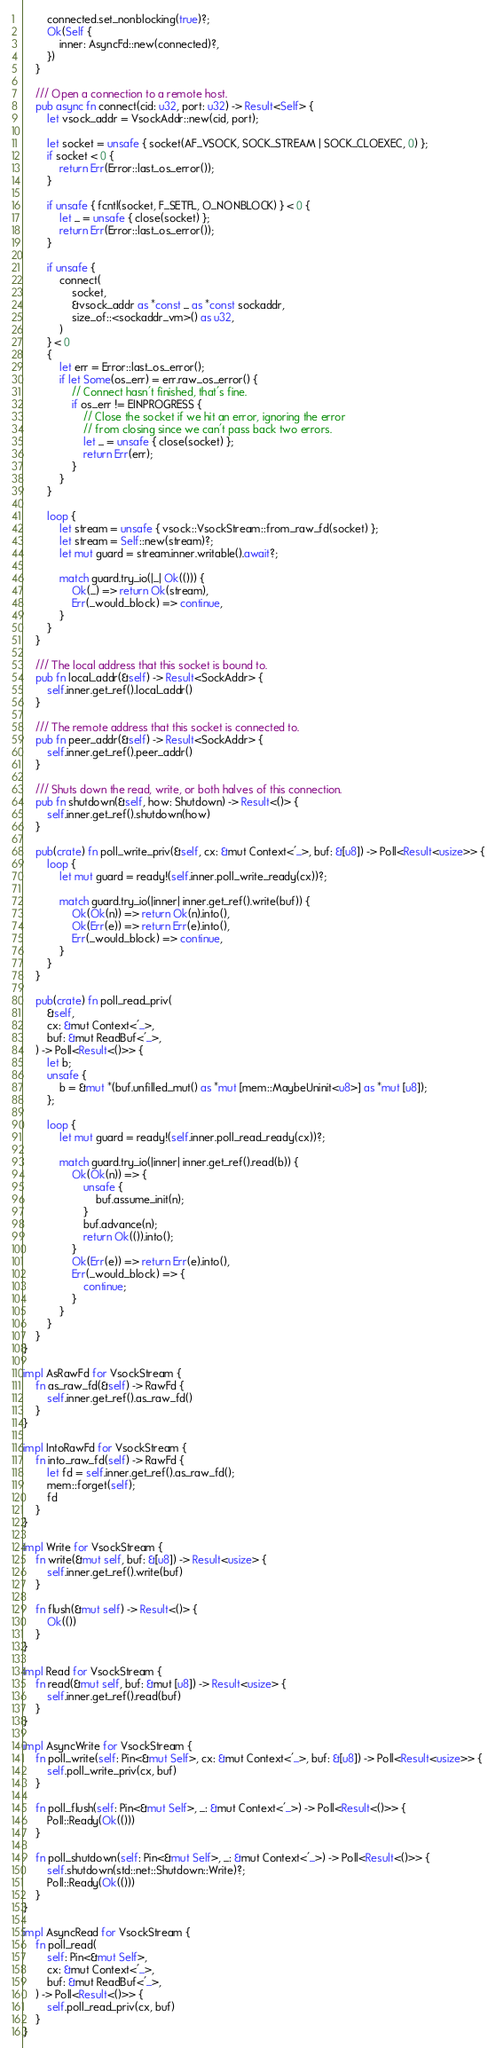<code> <loc_0><loc_0><loc_500><loc_500><_Rust_>        connected.set_nonblocking(true)?;
        Ok(Self {
            inner: AsyncFd::new(connected)?,
        })
    }

    /// Open a connection to a remote host.
    pub async fn connect(cid: u32, port: u32) -> Result<Self> {
        let vsock_addr = VsockAddr::new(cid, port);

        let socket = unsafe { socket(AF_VSOCK, SOCK_STREAM | SOCK_CLOEXEC, 0) };
        if socket < 0 {
            return Err(Error::last_os_error());
        }

        if unsafe { fcntl(socket, F_SETFL, O_NONBLOCK) } < 0 {
            let _ = unsafe { close(socket) };
            return Err(Error::last_os_error());
        }

        if unsafe {
            connect(
                socket,
                &vsock_addr as *const _ as *const sockaddr,
                size_of::<sockaddr_vm>() as u32,
            )
        } < 0
        {
            let err = Error::last_os_error();
            if let Some(os_err) = err.raw_os_error() {
                // Connect hasn't finished, that's fine.
                if os_err != EINPROGRESS {
                    // Close the socket if we hit an error, ignoring the error
                    // from closing since we can't pass back two errors.
                    let _ = unsafe { close(socket) };
                    return Err(err);
                }
            }
        }

        loop {
            let stream = unsafe { vsock::VsockStream::from_raw_fd(socket) };
            let stream = Self::new(stream)?;
            let mut guard = stream.inner.writable().await?;

            match guard.try_io(|_| Ok(())) {
                Ok(_) => return Ok(stream),
                Err(_would_block) => continue,
            }
        }
    }

    /// The local address that this socket is bound to.
    pub fn local_addr(&self) -> Result<SockAddr> {
        self.inner.get_ref().local_addr()
    }

    /// The remote address that this socket is connected to.
    pub fn peer_addr(&self) -> Result<SockAddr> {
        self.inner.get_ref().peer_addr()
    }

    /// Shuts down the read, write, or both halves of this connection.
    pub fn shutdown(&self, how: Shutdown) -> Result<()> {
        self.inner.get_ref().shutdown(how)
    }

    pub(crate) fn poll_write_priv(&self, cx: &mut Context<'_>, buf: &[u8]) -> Poll<Result<usize>> {
        loop {
            let mut guard = ready!(self.inner.poll_write_ready(cx))?;

            match guard.try_io(|inner| inner.get_ref().write(buf)) {
                Ok(Ok(n)) => return Ok(n).into(),
                Ok(Err(e)) => return Err(e).into(),
                Err(_would_block) => continue,
            }
        }
    }

    pub(crate) fn poll_read_priv(
        &self,
        cx: &mut Context<'_>,
        buf: &mut ReadBuf<'_>,
    ) -> Poll<Result<()>> {
        let b;
        unsafe {
            b = &mut *(buf.unfilled_mut() as *mut [mem::MaybeUninit<u8>] as *mut [u8]);
        };

        loop {
            let mut guard = ready!(self.inner.poll_read_ready(cx))?;

            match guard.try_io(|inner| inner.get_ref().read(b)) {
                Ok(Ok(n)) => {
                    unsafe {
                        buf.assume_init(n);
                    }
                    buf.advance(n);
                    return Ok(()).into();
                }
                Ok(Err(e)) => return Err(e).into(),
                Err(_would_block) => {
                    continue;
                }
            }
        }
    }
}

impl AsRawFd for VsockStream {
    fn as_raw_fd(&self) -> RawFd {
        self.inner.get_ref().as_raw_fd()
    }
}

impl IntoRawFd for VsockStream {
    fn into_raw_fd(self) -> RawFd {
        let fd = self.inner.get_ref().as_raw_fd();
        mem::forget(self);
        fd
    }
}

impl Write for VsockStream {
    fn write(&mut self, buf: &[u8]) -> Result<usize> {
        self.inner.get_ref().write(buf)
    }

    fn flush(&mut self) -> Result<()> {
        Ok(())
    }
}

impl Read for VsockStream {
    fn read(&mut self, buf: &mut [u8]) -> Result<usize> {
        self.inner.get_ref().read(buf)
    }
}

impl AsyncWrite for VsockStream {
    fn poll_write(self: Pin<&mut Self>, cx: &mut Context<'_>, buf: &[u8]) -> Poll<Result<usize>> {
        self.poll_write_priv(cx, buf)
    }

    fn poll_flush(self: Pin<&mut Self>, _: &mut Context<'_>) -> Poll<Result<()>> {
        Poll::Ready(Ok(()))
    }

    fn poll_shutdown(self: Pin<&mut Self>, _: &mut Context<'_>) -> Poll<Result<()>> {
        self.shutdown(std::net::Shutdown::Write)?;
        Poll::Ready(Ok(()))
    }
}

impl AsyncRead for VsockStream {
    fn poll_read(
        self: Pin<&mut Self>,
        cx: &mut Context<'_>,
        buf: &mut ReadBuf<'_>,
    ) -> Poll<Result<()>> {
        self.poll_read_priv(cx, buf)
    }
}
</code> 